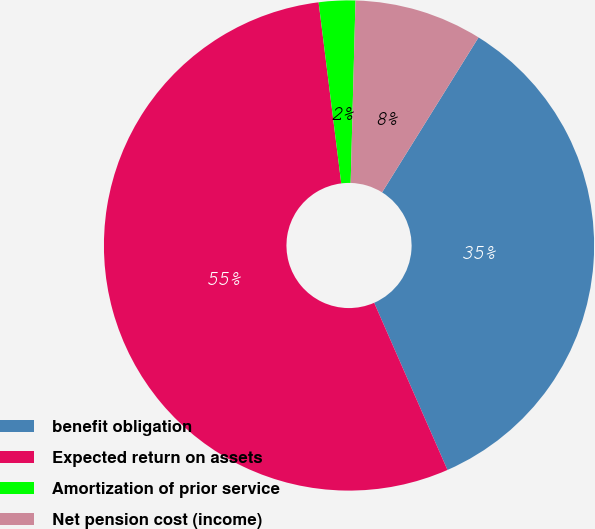Convert chart. <chart><loc_0><loc_0><loc_500><loc_500><pie_chart><fcel>benefit obligation<fcel>Expected return on assets<fcel>Amortization of prior service<fcel>Net pension cost (income)<nl><fcel>34.56%<fcel>54.6%<fcel>2.4%<fcel>8.44%<nl></chart> 